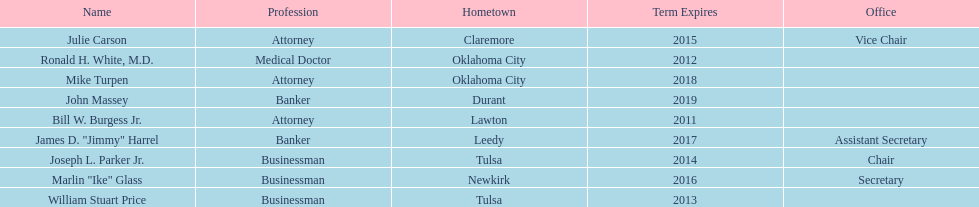Parse the table in full. {'header': ['Name', 'Profession', 'Hometown', 'Term Expires', 'Office'], 'rows': [['Julie Carson', 'Attorney', 'Claremore', '2015', 'Vice Chair'], ['Ronald H. White, M.D.', 'Medical Doctor', 'Oklahoma City', '2012', ''], ['Mike Turpen', 'Attorney', 'Oklahoma City', '2018', ''], ['John Massey', 'Banker', 'Durant', '2019', ''], ['Bill W. Burgess Jr.', 'Attorney', 'Lawton', '2011', ''], ['James D. "Jimmy" Harrel', 'Banker', 'Leedy', '2017', 'Assistant Secretary'], ['Joseph L. Parker Jr.', 'Businessman', 'Tulsa', '2014', 'Chair'], ['Marlin "Ike" Glass', 'Businessman', 'Newkirk', '2016', 'Secretary'], ['William Stuart Price', 'Businessman', 'Tulsa', '2013', '']]} Total number of members from lawton and oklahoma city 3. 